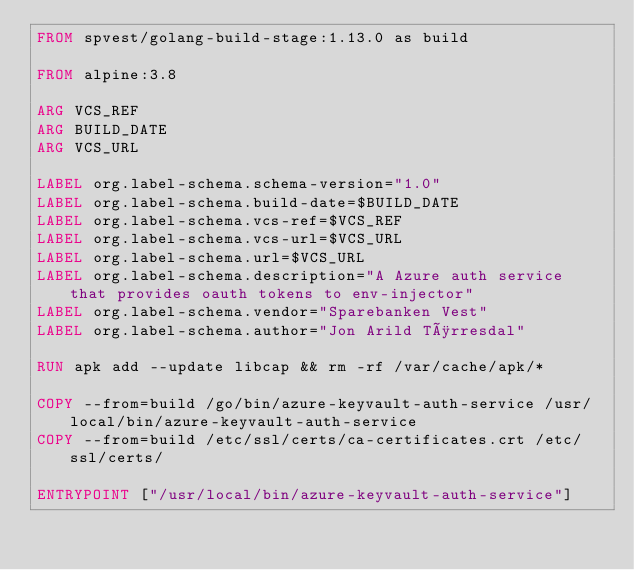Convert code to text. <code><loc_0><loc_0><loc_500><loc_500><_Dockerfile_>FROM spvest/golang-build-stage:1.13.0 as build

FROM alpine:3.8

ARG VCS_REF
ARG BUILD_DATE
ARG VCS_URL

LABEL org.label-schema.schema-version="1.0"
LABEL org.label-schema.build-date=$BUILD_DATE
LABEL org.label-schema.vcs-ref=$VCS_REF
LABEL org.label-schema.vcs-url=$VCS_URL
LABEL org.label-schema.url=$VCS_URL
LABEL org.label-schema.description="A Azure auth service that provides oauth tokens to env-injector"
LABEL org.label-schema.vendor="Sparebanken Vest"      
LABEL org.label-schema.author="Jon Arild Tørresdal"

RUN apk add --update libcap && rm -rf /var/cache/apk/*

COPY --from=build /go/bin/azure-keyvault-auth-service /usr/local/bin/azure-keyvault-auth-service
COPY --from=build /etc/ssl/certs/ca-certificates.crt /etc/ssl/certs/

ENTRYPOINT ["/usr/local/bin/azure-keyvault-auth-service"]</code> 